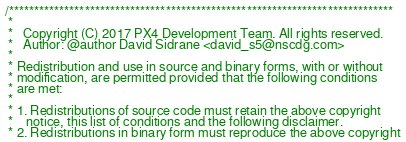<code> <loc_0><loc_0><loc_500><loc_500><_C_>/****************************************************************************
 *
 *   Copyright (C) 2017 PX4 Development Team. All rights reserved.
 *   Author: @author David Sidrane <david_s5@nscdg.com>
 *
 * Redistribution and use in source and binary forms, with or without
 * modification, are permitted provided that the following conditions
 * are met:
 *
 * 1. Redistributions of source code must retain the above copyright
 *    notice, this list of conditions and the following disclaimer.
 * 2. Redistributions in binary form must reproduce the above copyright</code> 